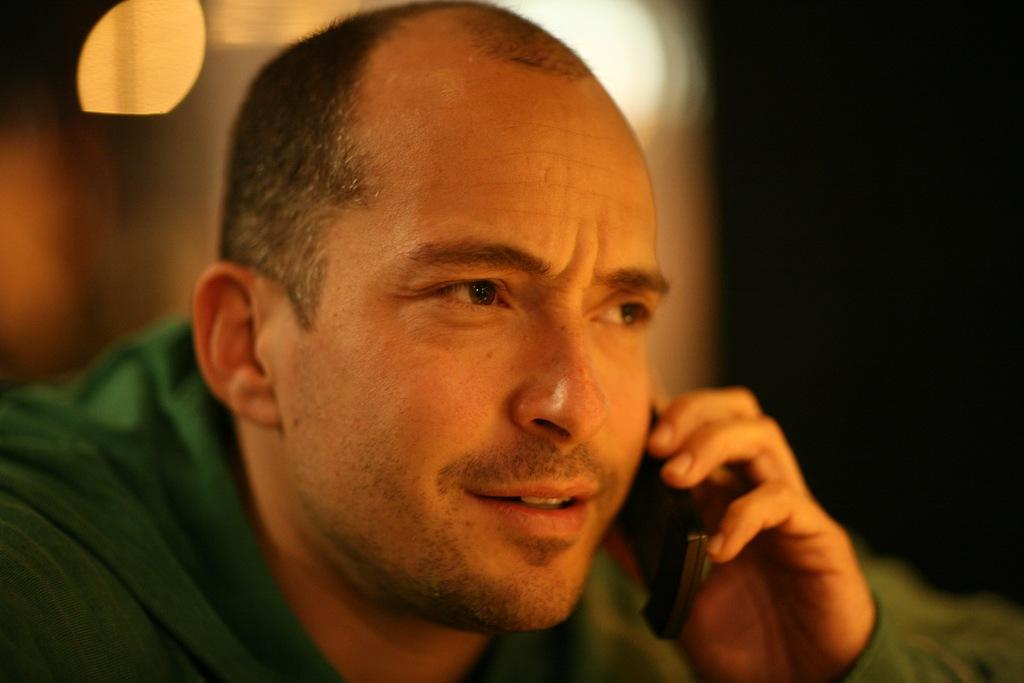Who or what is the main subject of the image? There is a person in the image. What is the person wearing? The person is wearing a green jacket. What object is the person holding in his hand? The person is holding a mobile in his hand. Can you describe the background of the image? The background of the image is blurry. Is the person wearing a crown in the image? There is no crown visible in the image. What type of battle is taking place in the background? There is no battle present in the image; the background is blurry. 